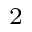<formula> <loc_0><loc_0><loc_500><loc_500>^ { 2 }</formula> 